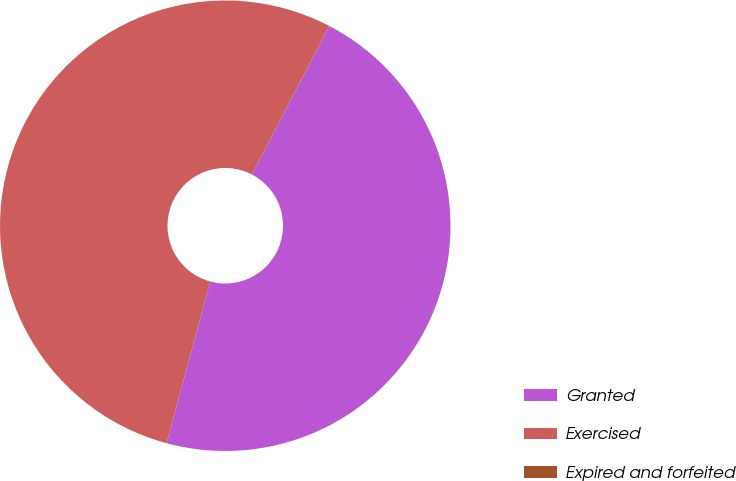Convert chart to OTSL. <chart><loc_0><loc_0><loc_500><loc_500><pie_chart><fcel>Granted<fcel>Exercised<fcel>Expired and forfeited<nl><fcel>46.54%<fcel>53.42%<fcel>0.03%<nl></chart> 